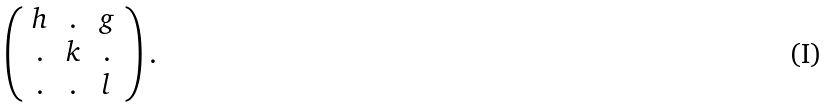Convert formula to latex. <formula><loc_0><loc_0><loc_500><loc_500>\left ( \begin{array} { c c c } h & . & g \\ . & k & . \\ . & . & l \end{array} \right ) .</formula> 